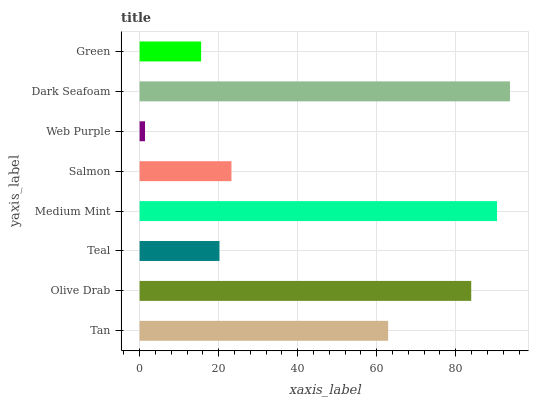Is Web Purple the minimum?
Answer yes or no. Yes. Is Dark Seafoam the maximum?
Answer yes or no. Yes. Is Olive Drab the minimum?
Answer yes or no. No. Is Olive Drab the maximum?
Answer yes or no. No. Is Olive Drab greater than Tan?
Answer yes or no. Yes. Is Tan less than Olive Drab?
Answer yes or no. Yes. Is Tan greater than Olive Drab?
Answer yes or no. No. Is Olive Drab less than Tan?
Answer yes or no. No. Is Tan the high median?
Answer yes or no. Yes. Is Salmon the low median?
Answer yes or no. Yes. Is Green the high median?
Answer yes or no. No. Is Medium Mint the low median?
Answer yes or no. No. 